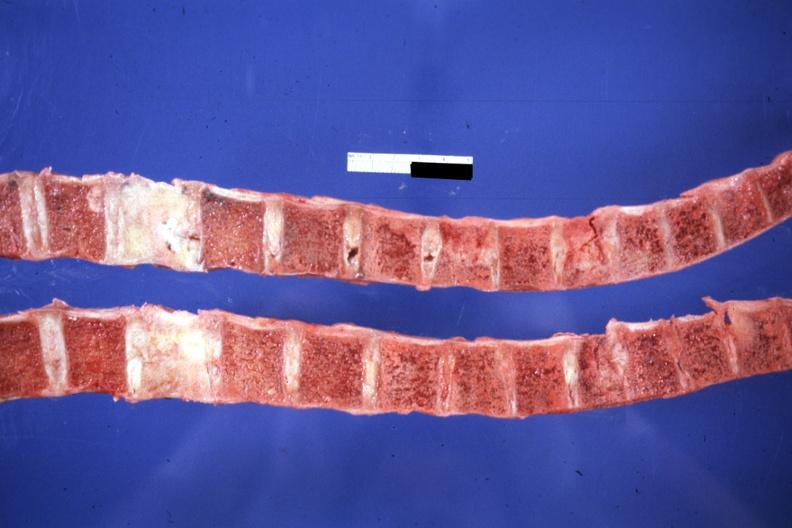does this image show saggital section typical do not know history but probably breast lesion?
Answer the question using a single word or phrase. Yes 